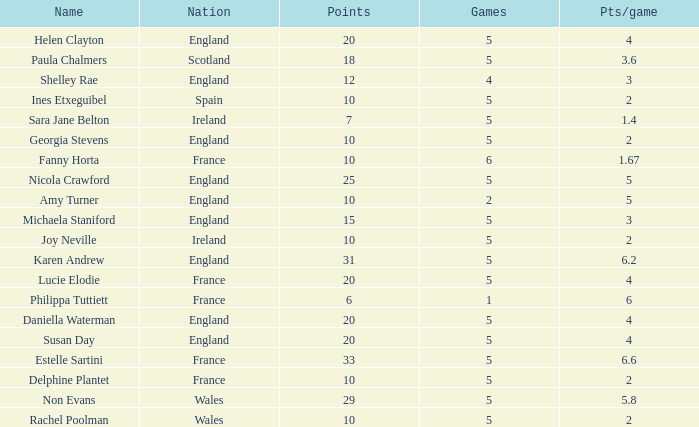Can you tell me the lowest Pts/game that has the Games larger than 6? None. 